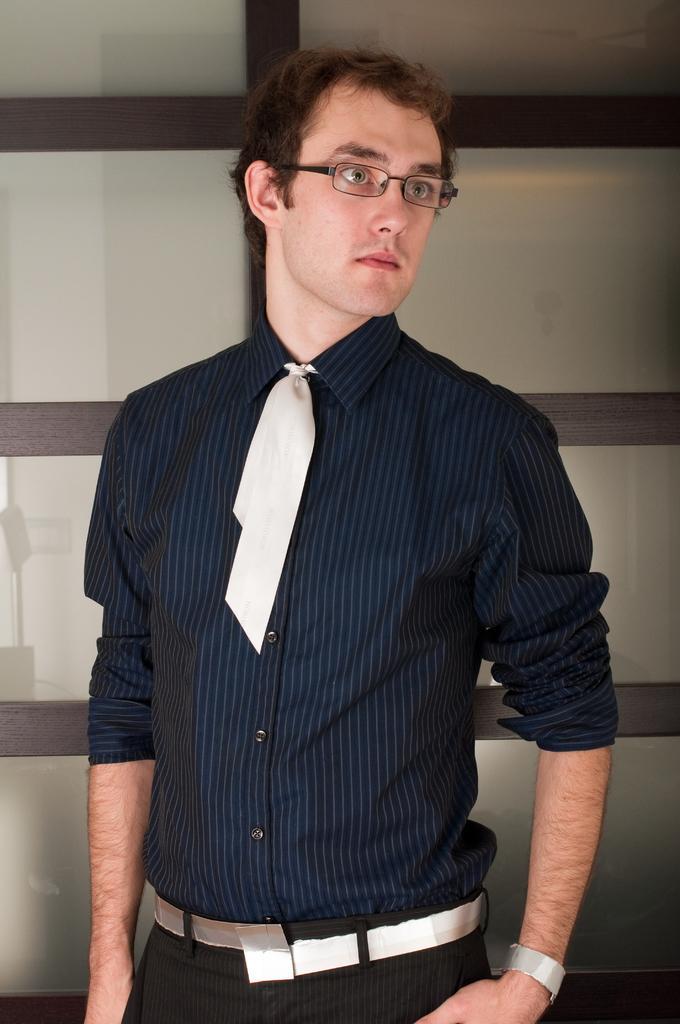Could you give a brief overview of what you see in this image? In this image we can see a person wearing blue color shirt, black color pant and wearing a tie also spectacles and at the background of the image there is glass door. 